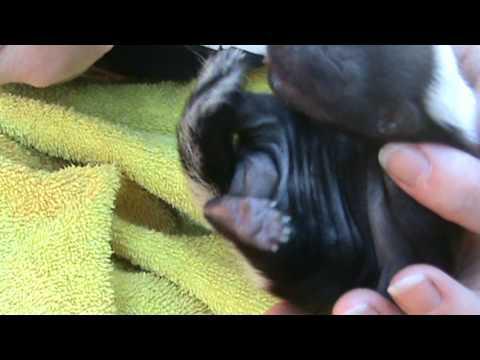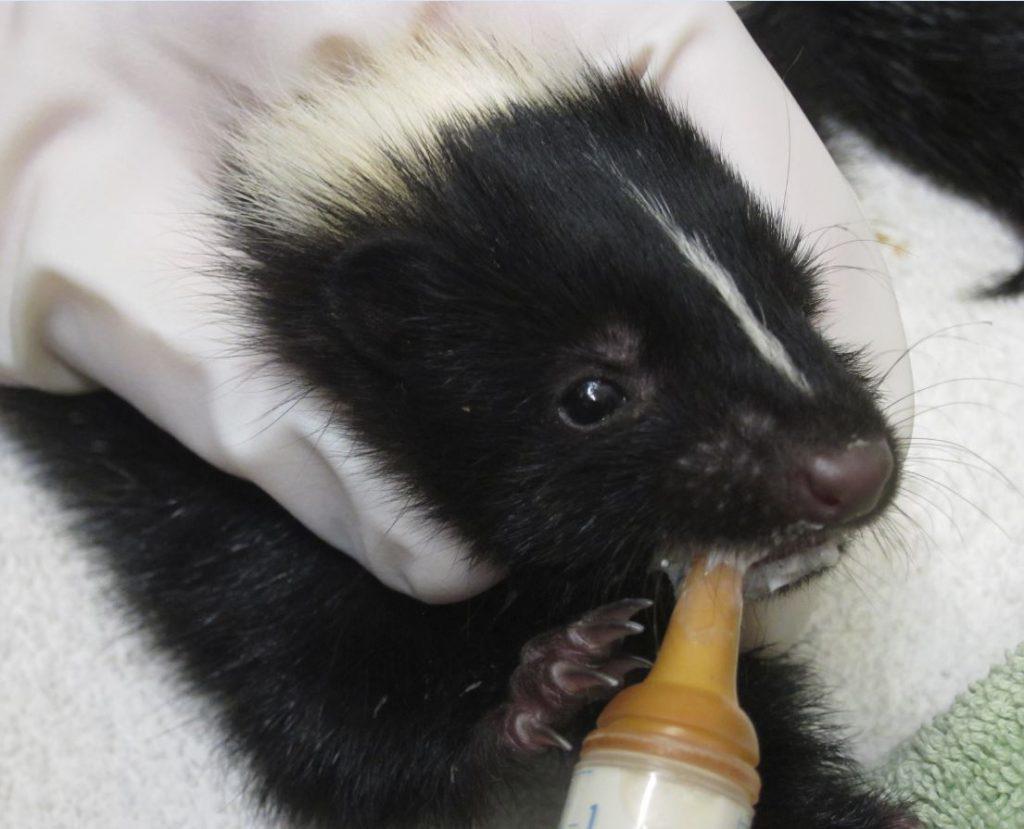The first image is the image on the left, the second image is the image on the right. Examine the images to the left and right. Is the description "The skunk in the right image is being bottle fed." accurate? Answer yes or no. Yes. The first image is the image on the left, the second image is the image on the right. Assess this claim about the two images: "One image features a hand holding up a leftward-turned baby skunk, which is feeding from a syringe.". Correct or not? Answer yes or no. No. 